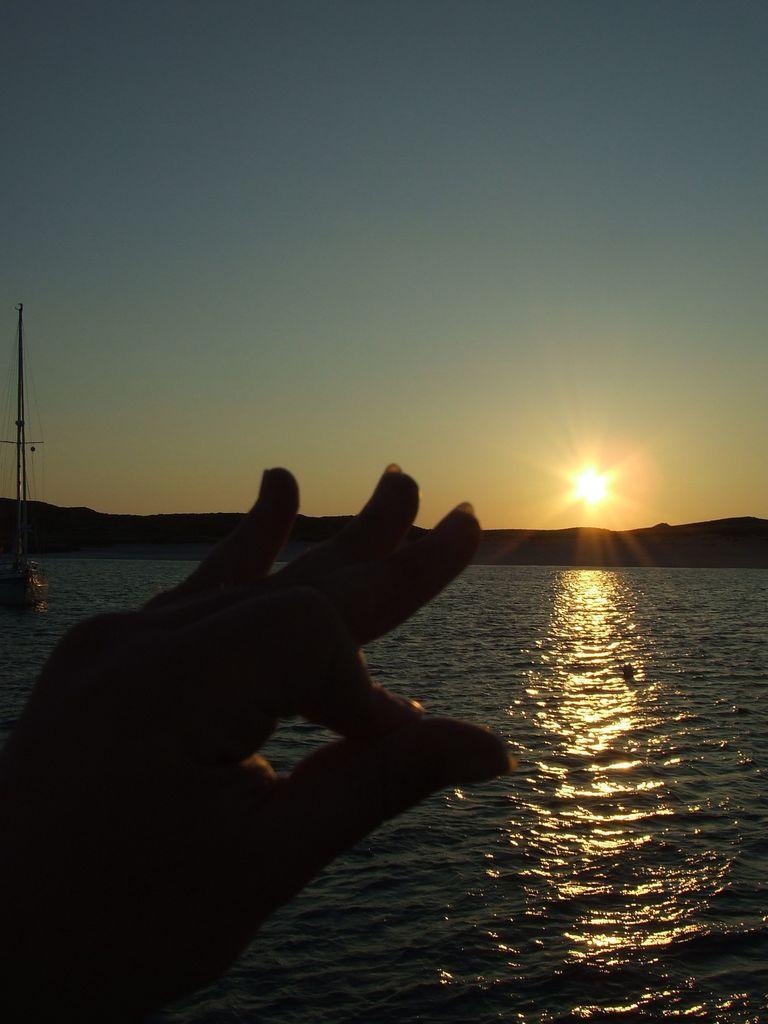How would you summarize this image in a sentence or two? Bottom left side of the image there is a hand. Behind the hand there is water. Top right side of the image there is sun. Top of the image there is sky. Top left side of the image there is a tower. 